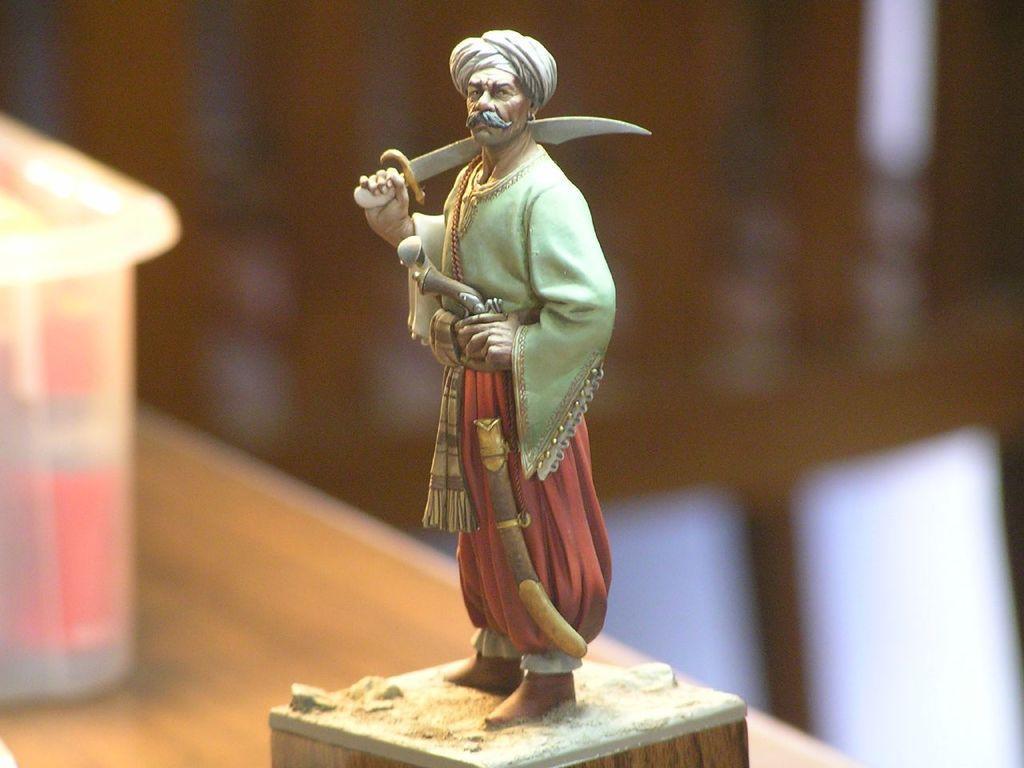Can you describe this image briefly? In this picture there is a sculpture of a person, he is standing and holding the sword. There is a sculpture and box on the table. At the back the image is blurry. 